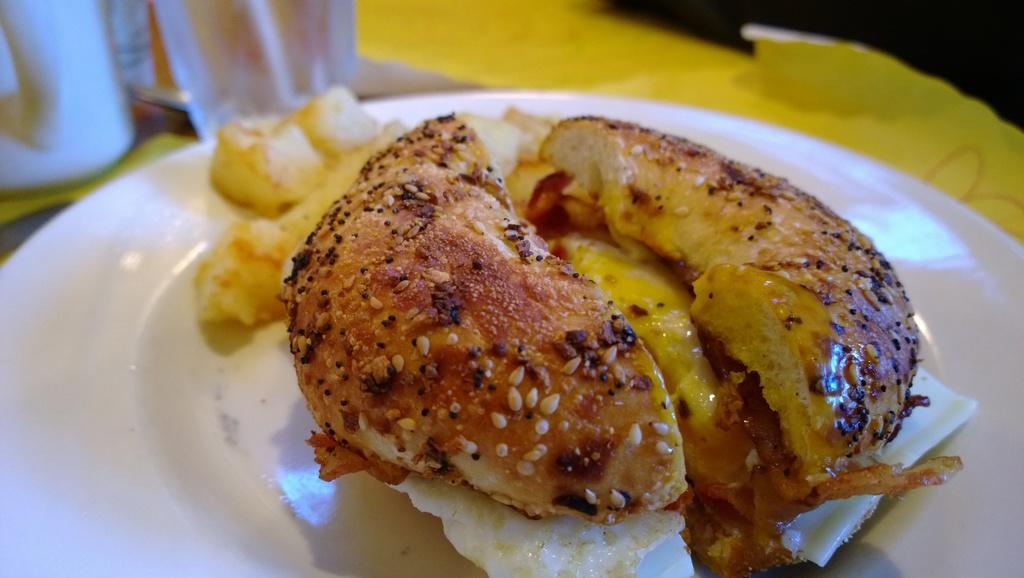What is present on the plate in the image? There is food in a plate in the image. What type of engine is visible in the image? There is no engine present in the image; it features a plate of food. What is the head doing in the image? There is no head present in the image; it features a plate of food. 